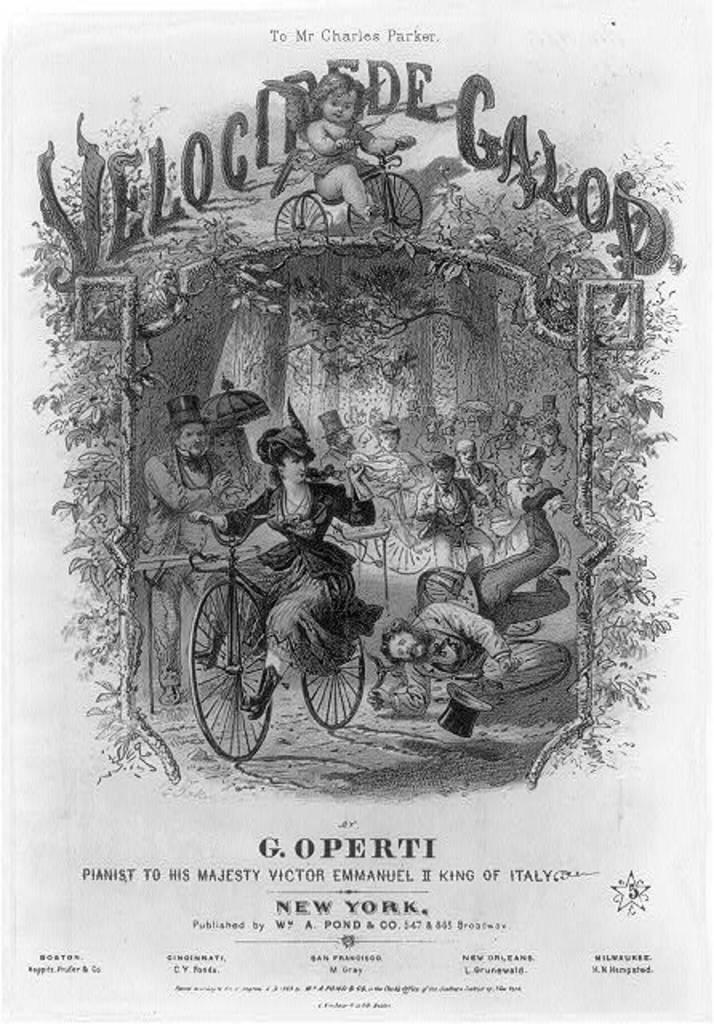In one or two sentences, can you explain what this image depicts? In the foreground of this poster, there is some text on the top and bottom and we can also see a woman riding bicycle and trees and persons in the background. 